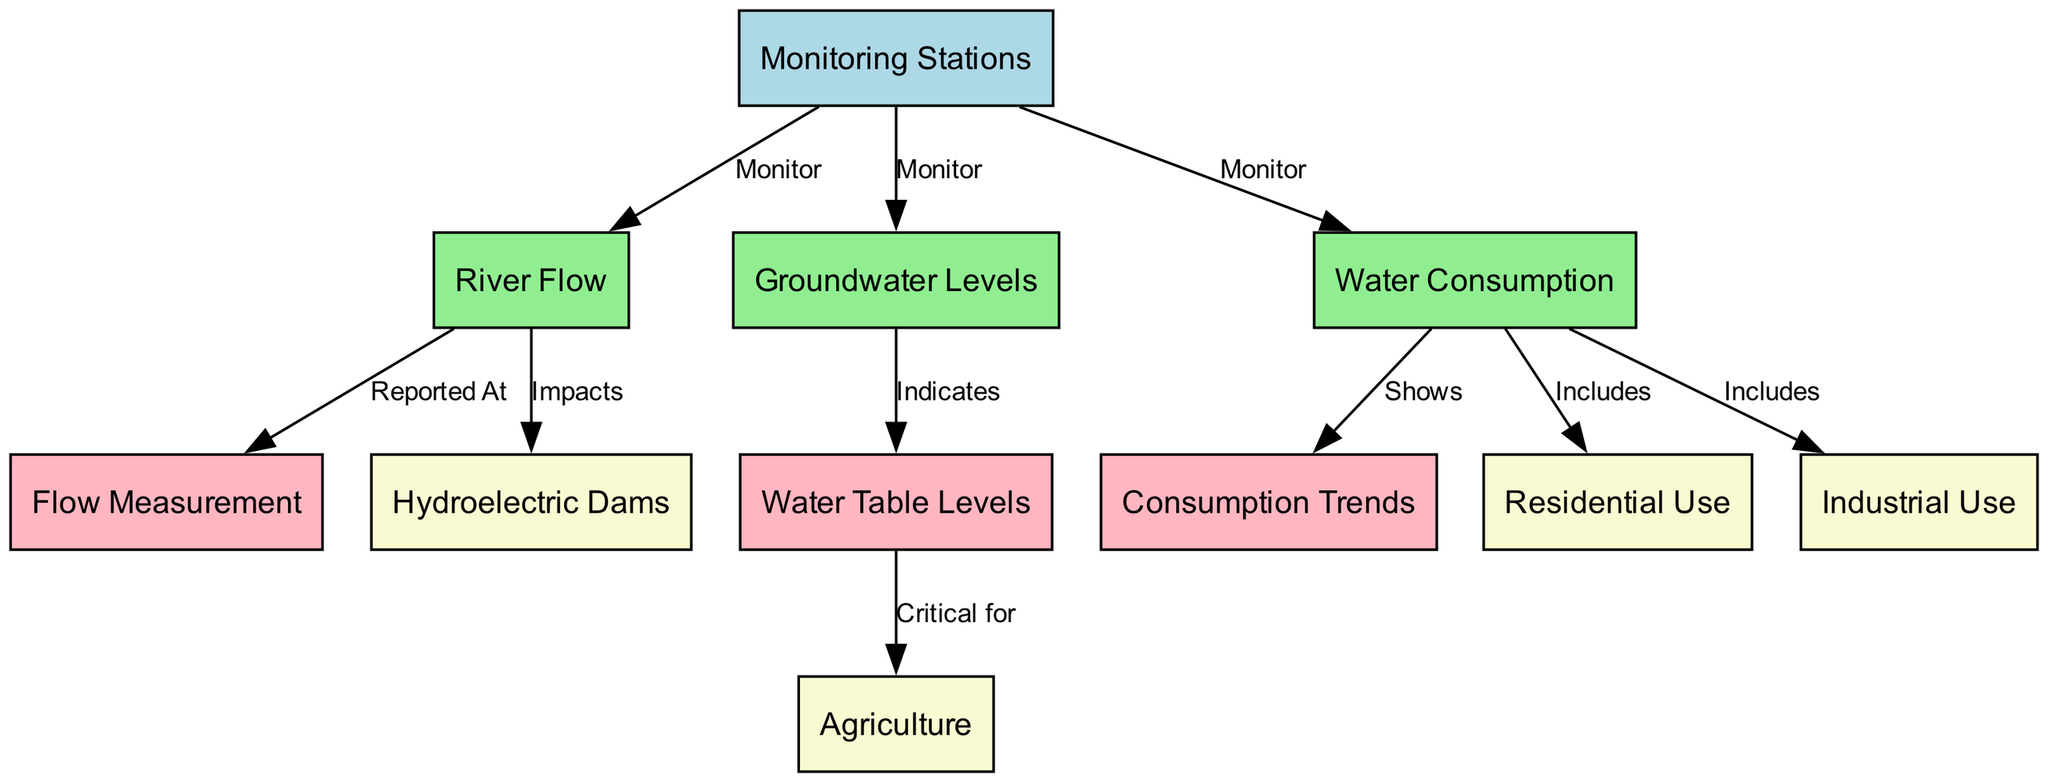What nodes are included in the diagram? The diagram includes the following nodes: River Flow, Groundwater Levels, Water Consumption, Monitoring Stations, Flow Measurement, Water Table Levels, Consumption Trends, Hydroelectric Dams, Agriculture, Residential Use, and Industrial Use. Each node represents a different aspect of local water resources management.
Answer: River Flow, Groundwater Levels, Water Consumption, Monitoring Stations, Flow Measurement, Water Table Levels, Consumption Trends, Hydroelectric Dams, Agriculture, Residential Use, Industrial Use How many edges are in the diagram? The diagram contains a total of 10 edges. Each edge represents a monitored relationship or impact between two nodes, and counting the edges visually from the diagram confirms this number.
Answer: 10 What does the "monitoring stations" node connect to? The "monitoring stations" node connects to three nodes: River Flow, Groundwater Levels, and Water Consumption. This indicates that monitoring stations are responsible for monitoring these specific aspects of water resources.
Answer: River Flow, Groundwater Levels, Water Consumption Which node indicates the "water tables" levels? The "water tables" levels are indicated by the node "Groundwater Levels." The edge from "Groundwater Levels" to "Water Table Levels" shows that it is a representation of the water table condition based on groundwater monitoring.
Answer: Groundwater Levels How does the "river flow" affect "hydroelectric dams"? The "river flow" impacts "hydroelectric dams," as indicated by the direct edge from "river flow" to "hydroelectric dams." This suggests that changes in river flow have direct implications for hydroelectric power generation capabilities.
Answer: Impacts What is a critical use of "water tables"? The node "Water Table Levels" is critical for the "Agriculture" node, as indicated by the edge that states "Critical for." This highlights the importance of groundwater levels in agricultural practices and sustainability.
Answer: Agriculture What do "water consumption" trends show for us? The "water consumption" node shows trends through the node "Consumption Trends." This relationship illustrates how consumption patterns over time can provide insights into overall water usage strategies and areas needing improvement.
Answer: Shows Which categories are included in "water consumption"? The "water consumption" node includes three categories: Residential Use, Industrial Use, and Agriculture. The edges point out that these are the primary contributors to water consumption in the region.
Answer: Residential Use, Industrial Use, Agriculture What does the "flow measurement" node report on? The "flow measurement" node is reported at by the "river flow" node. This indicates that measurements of river flow are collected and can demonstrate the health and capacity of the river over time.
Answer: Reported At 